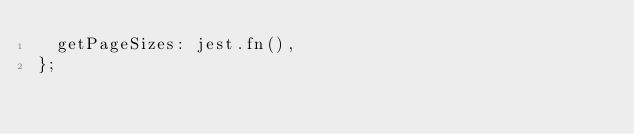Convert code to text. <code><loc_0><loc_0><loc_500><loc_500><_TypeScript_>  getPageSizes: jest.fn(),
};
</code> 